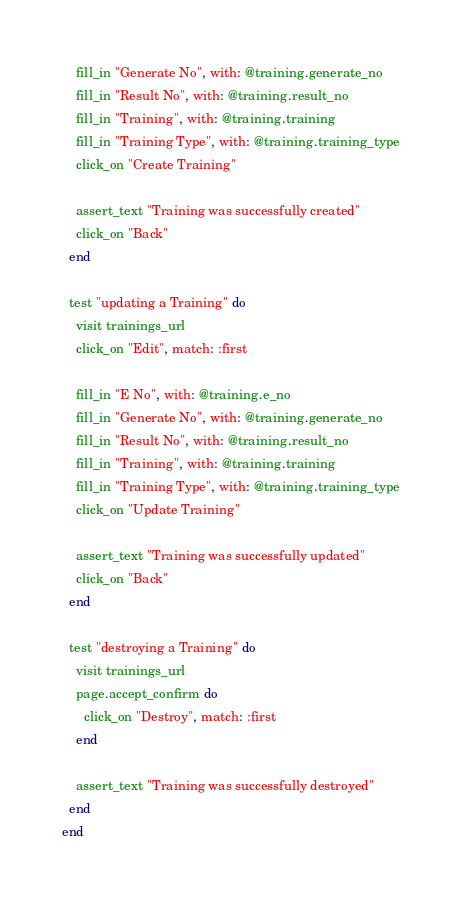<code> <loc_0><loc_0><loc_500><loc_500><_Ruby_>    fill_in "Generate No", with: @training.generate_no
    fill_in "Result No", with: @training.result_no
    fill_in "Training", with: @training.training
    fill_in "Training Type", with: @training.training_type
    click_on "Create Training"

    assert_text "Training was successfully created"
    click_on "Back"
  end

  test "updating a Training" do
    visit trainings_url
    click_on "Edit", match: :first

    fill_in "E No", with: @training.e_no
    fill_in "Generate No", with: @training.generate_no
    fill_in "Result No", with: @training.result_no
    fill_in "Training", with: @training.training
    fill_in "Training Type", with: @training.training_type
    click_on "Update Training"

    assert_text "Training was successfully updated"
    click_on "Back"
  end

  test "destroying a Training" do
    visit trainings_url
    page.accept_confirm do
      click_on "Destroy", match: :first
    end

    assert_text "Training was successfully destroyed"
  end
end
</code> 